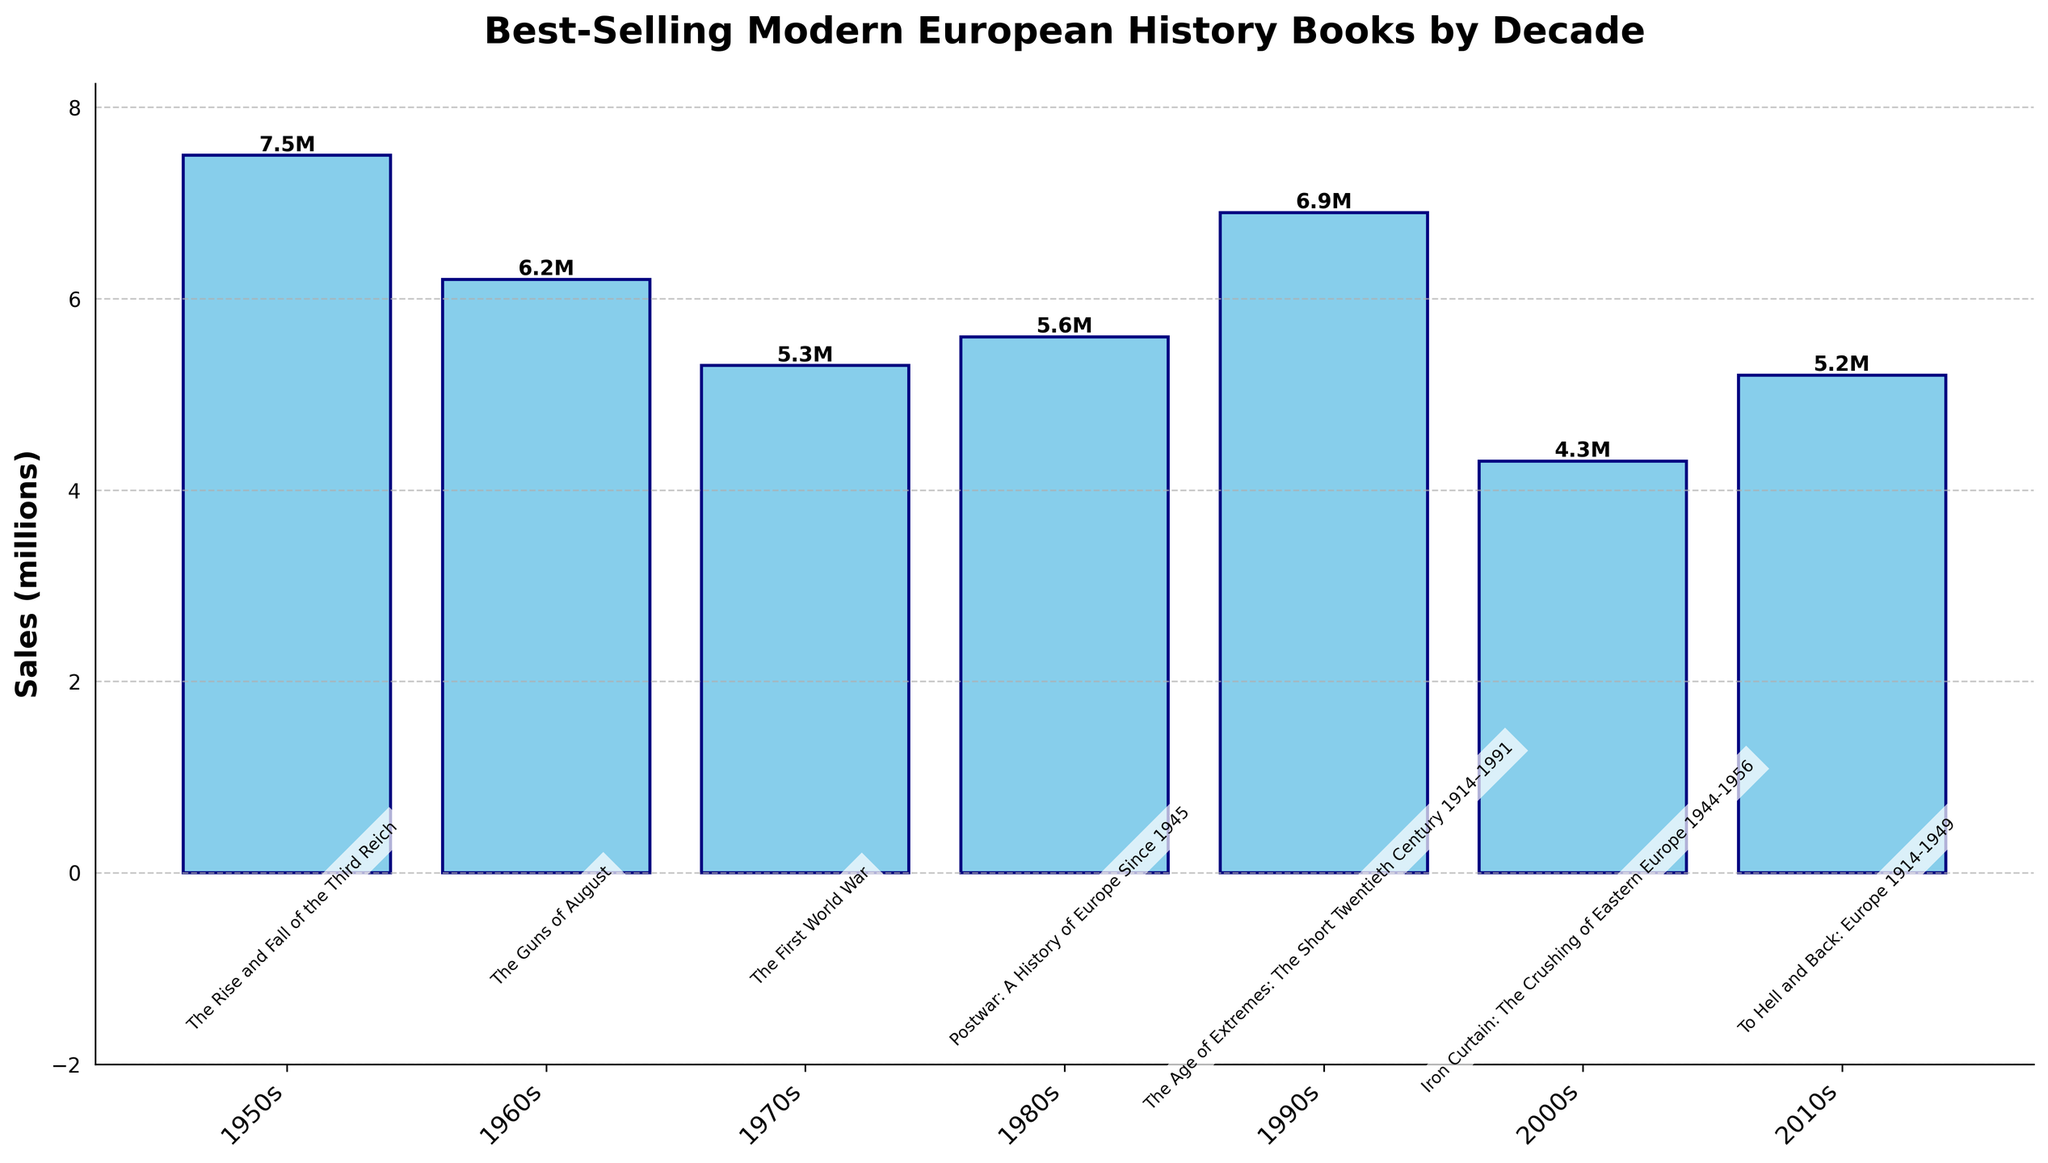What's the best-selling book of the 1950s? The bar for the 1950s shows the title "The Rise and Fall of the Third Reich" with the highest sales for that decade.
Answer: "The Rise and Fall of the Third Reich" What's the total sales for the best-selling books in the 2000s and 2010s combined? The sales for the top book in the 2000s is 4.3 million, and for the 2010s it is 5.2 million. So, the total sales are 4.3 + 5.2 = 9.5 million.
Answer: 9.5 million Which decade had the lowest sales for its top-selling book? The bar for the 2000s shows the lowest height among all bars with a sales figure of 4.3 million for the top-selling book.
Answer: 2000s What is the difference in sales between the top-selling book of the 1960s and the top-selling book of the 1970s? The sales for the best-selling book in the 1960s is 6.2 million, and for the 1970s it is 5.3 million. Thus, the difference is 6.2 - 5.3 = 0.9 million.
Answer: 0.9 million Which decade is represented by the book "The Guns of August"? The bar labeled "The Guns of August" corresponds to the 1960s.
Answer: 1960s How many decades have best-selling books that sold more than 5 million copies? The bars for the 1950s, 1960s, 1990s, 2000s, and 2010s display sales figures greater than 5 million. These are 5 out of the 7 decades.
Answer: 5 decades Does the 1980s or 1990s have higher sales for its top book, and by how much? The sales for the 1990s is 6.9 million, while the sales for the 1980s is 5.6 million. The difference is 6.9 - 5.6 = 1.3 million, showing that the 1990s had higher sales.
Answer: 1990s, 1.3 million What is the title of the top-selling book in the decade where "Bloodlands: Europe Between Hitler and Stalin" was second-ranked? "Bloodlands: Europe Between Hitler and Stalin" is depicted under the 2010s. Therefore, the top-selling book for the 2010s is "To Hell and Back: Europe 1914-1949".
Answer: "To Hell and Back: Europe 1914-1949" What is the average sales figure for the top books from the 1990s and 2000s? The sales figure for the 1990s top book is 6.9 million, and for the 2000s top book is 4.3 million. The average is (6.9 + 4.3) / 2 = 11.2 / 2 = 5.6 million.
Answer: 5.6 million 